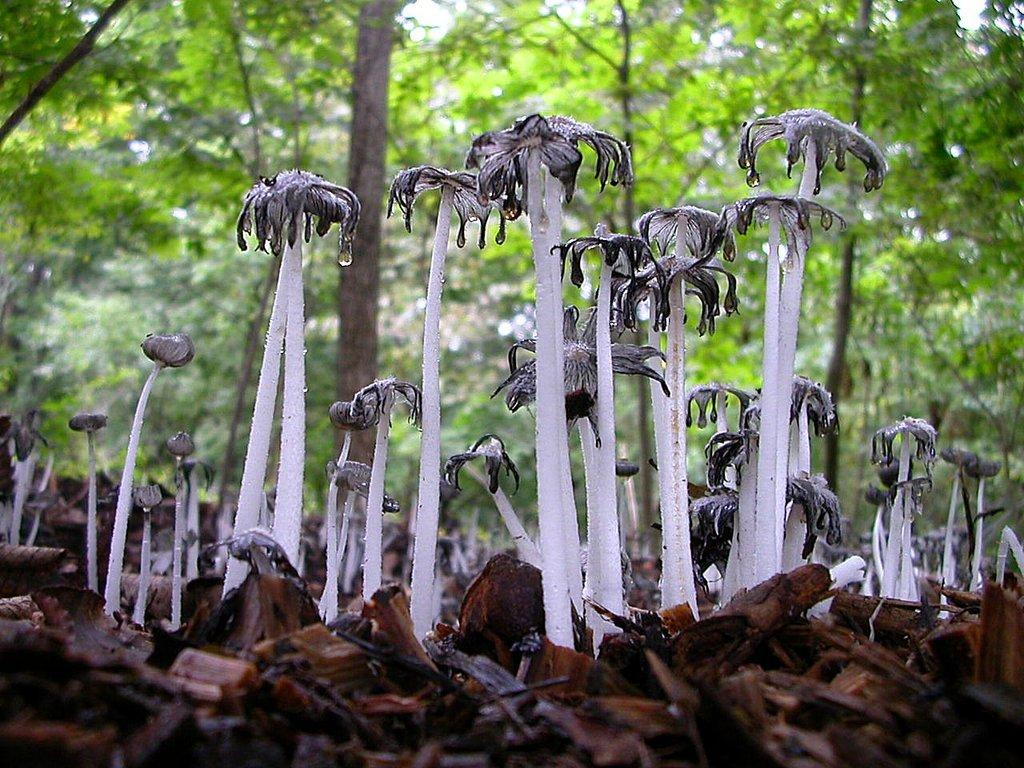What type of vegetation can be seen on the ground in the image? There are mushrooms on the ground in the image. What other natural elements can be seen in the image? There are trees in the image. Can you see a pickle hanging from one of the trees in the image? There is no pickle present in the image; it features mushrooms on the ground and trees. Is there a swing attached to any of the trees in the image? There is no swing present in the image; it only shows mushrooms on the ground and trees. 